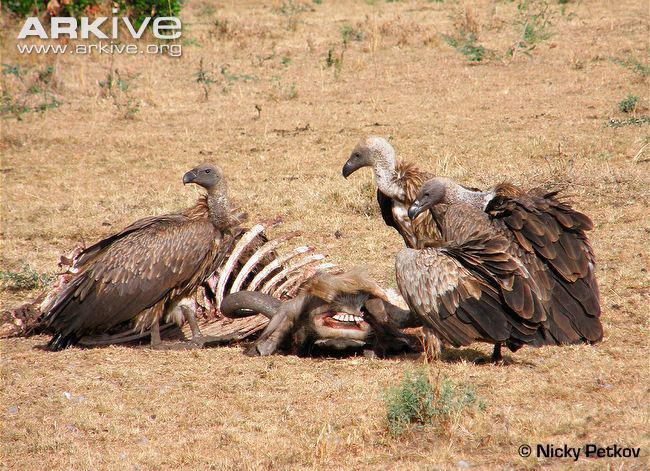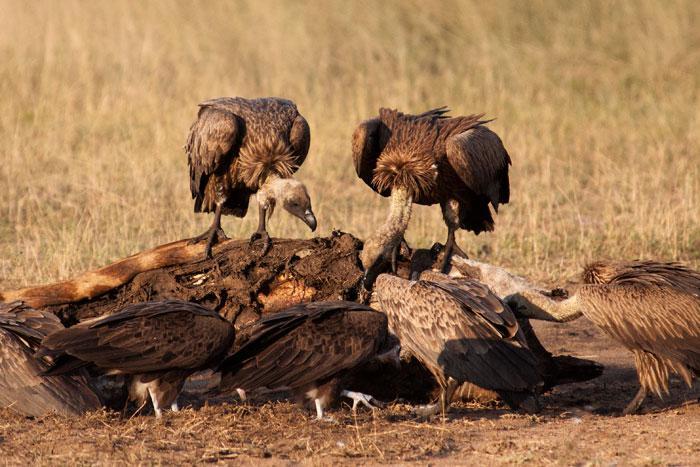The first image is the image on the left, the second image is the image on the right. Given the left and right images, does the statement "The left image contains exactly two vultures." hold true? Answer yes or no. Yes. 